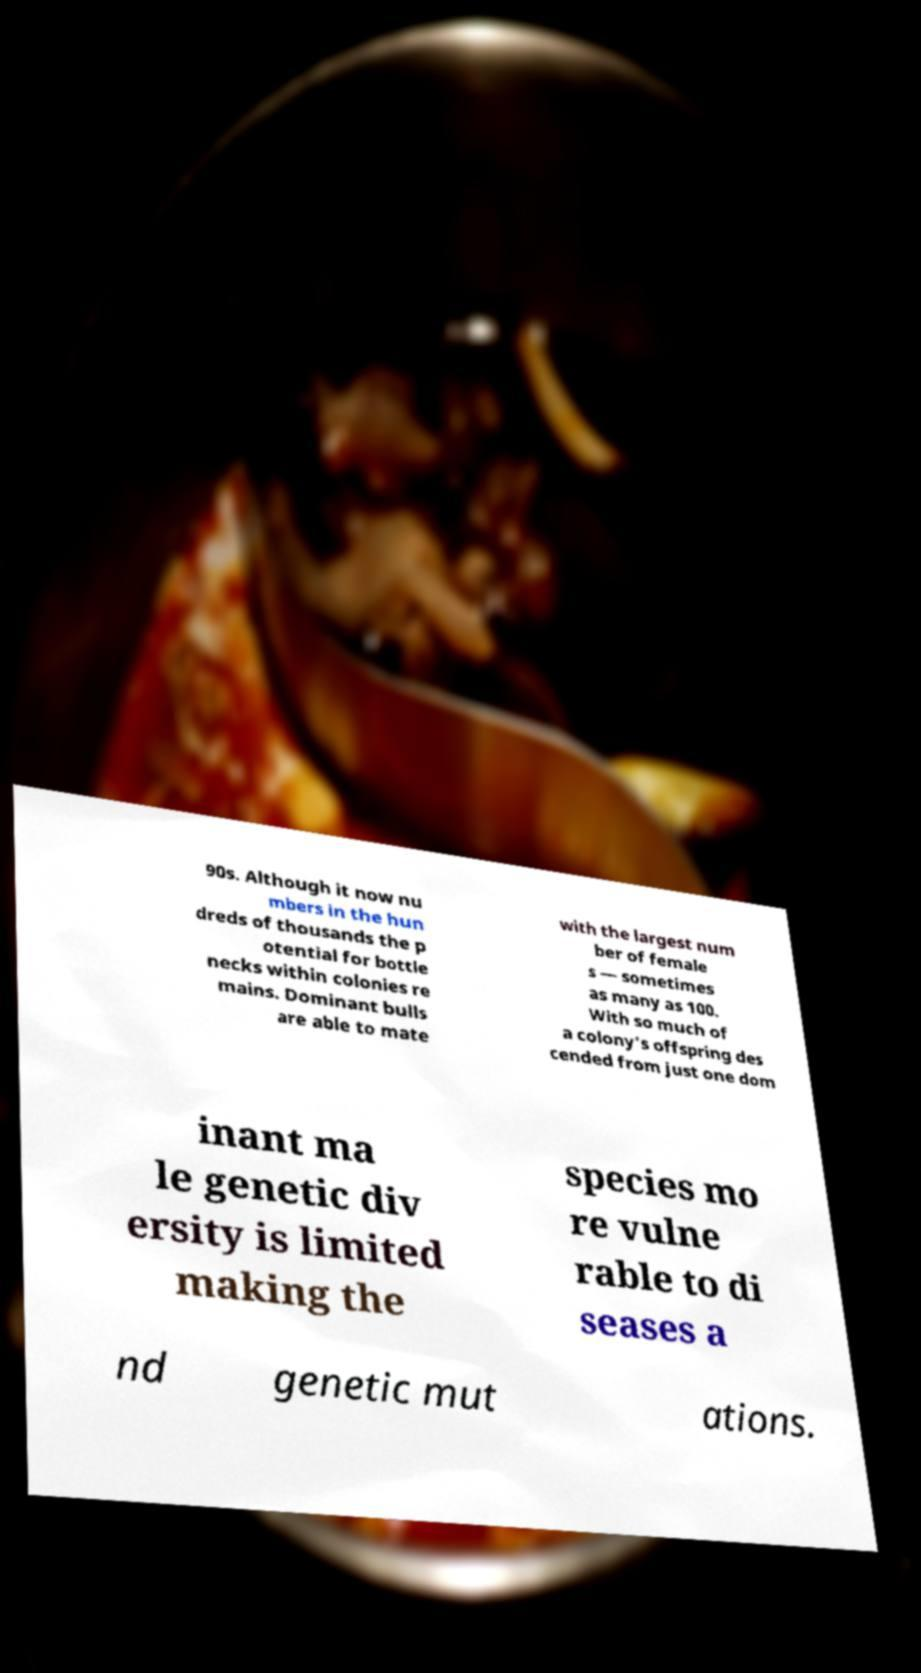Could you extract and type out the text from this image? 90s. Although it now nu mbers in the hun dreds of thousands the p otential for bottle necks within colonies re mains. Dominant bulls are able to mate with the largest num ber of female s — sometimes as many as 100. With so much of a colony's offspring des cended from just one dom inant ma le genetic div ersity is limited making the species mo re vulne rable to di seases a nd genetic mut ations. 